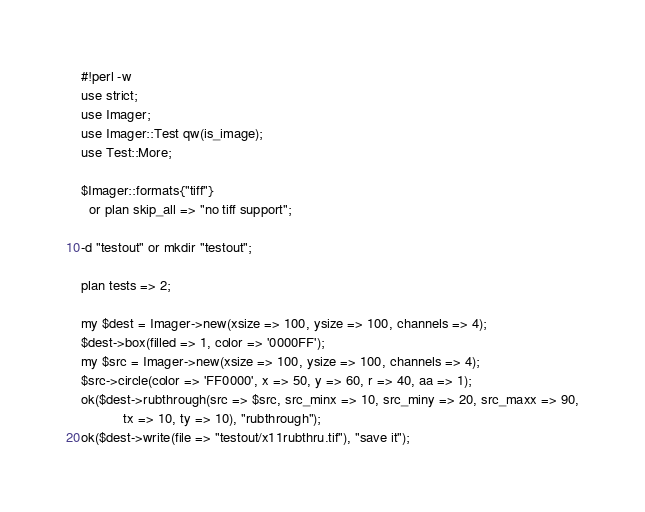<code> <loc_0><loc_0><loc_500><loc_500><_Perl_>#!perl -w
use strict;
use Imager;
use Imager::Test qw(is_image);
use Test::More;

$Imager::formats{"tiff"}
  or plan skip_all => "no tiff support";

-d "testout" or mkdir "testout";

plan tests => 2;

my $dest = Imager->new(xsize => 100, ysize => 100, channels => 4);
$dest->box(filled => 1, color => '0000FF');
my $src = Imager->new(xsize => 100, ysize => 100, channels => 4);
$src->circle(color => 'FF0000', x => 50, y => 60, r => 40, aa => 1);
ok($dest->rubthrough(src => $src, src_minx => 10, src_miny => 20, src_maxx => 90,
	       tx => 10, ty => 10), "rubthrough");
ok($dest->write(file => "testout/x11rubthru.tif"), "save it");

</code> 